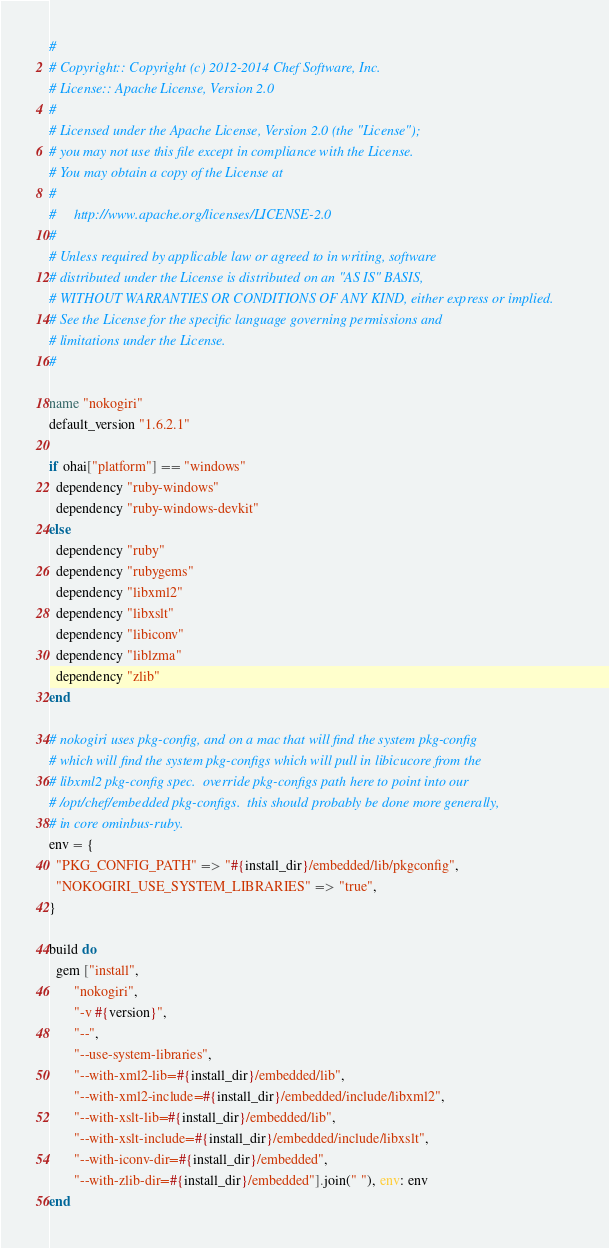<code> <loc_0><loc_0><loc_500><loc_500><_Ruby_>#
# Copyright:: Copyright (c) 2012-2014 Chef Software, Inc.
# License:: Apache License, Version 2.0
#
# Licensed under the Apache License, Version 2.0 (the "License");
# you may not use this file except in compliance with the License.
# You may obtain a copy of the License at
#
#     http://www.apache.org/licenses/LICENSE-2.0
#
# Unless required by applicable law or agreed to in writing, software
# distributed under the License is distributed on an "AS IS" BASIS,
# WITHOUT WARRANTIES OR CONDITIONS OF ANY KIND, either express or implied.
# See the License for the specific language governing permissions and
# limitations under the License.
#

name "nokogiri"
default_version "1.6.2.1"

if ohai["platform"] == "windows"
  dependency "ruby-windows"
  dependency "ruby-windows-devkit"
else
  dependency "ruby"
  dependency "rubygems"
  dependency "libxml2"
  dependency "libxslt"
  dependency "libiconv"
  dependency "liblzma"
  dependency "zlib"
end

# nokogiri uses pkg-config, and on a mac that will find the system pkg-config
# which will find the system pkg-configs which will pull in libicucore from the
# libxml2 pkg-config spec.  override pkg-configs path here to point into our
# /opt/chef/embedded pkg-configs.  this should probably be done more generally,
# in core ominbus-ruby.
env = {
  "PKG_CONFIG_PATH" => "#{install_dir}/embedded/lib/pkgconfig",
  "NOKOGIRI_USE_SYSTEM_LIBRARIES" => "true",
}

build do
  gem ["install",
       "nokogiri",
       "-v #{version}",
       "--",
       "--use-system-libraries",
       "--with-xml2-lib=#{install_dir}/embedded/lib",
       "--with-xml2-include=#{install_dir}/embedded/include/libxml2",
       "--with-xslt-lib=#{install_dir}/embedded/lib",
       "--with-xslt-include=#{install_dir}/embedded/include/libxslt",
       "--with-iconv-dir=#{install_dir}/embedded",
       "--with-zlib-dir=#{install_dir}/embedded"].join(" "), env: env
end
</code> 